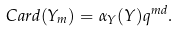<formula> <loc_0><loc_0><loc_500><loc_500>\, C a r d ( Y _ { m } ) = \alpha _ { Y } ( Y ) q ^ { m d } .</formula> 